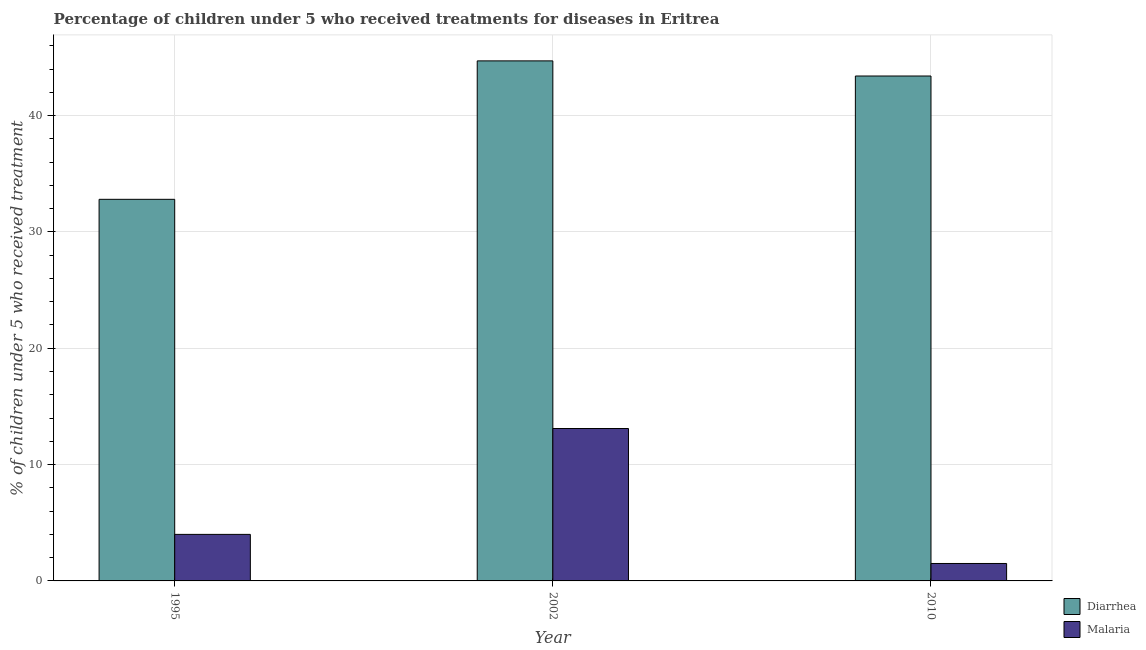How many groups of bars are there?
Your answer should be very brief. 3. What is the label of the 3rd group of bars from the left?
Provide a succinct answer. 2010. Across all years, what is the maximum percentage of children who received treatment for diarrhoea?
Give a very brief answer. 44.7. Across all years, what is the minimum percentage of children who received treatment for malaria?
Your answer should be very brief. 1.5. In which year was the percentage of children who received treatment for diarrhoea maximum?
Keep it short and to the point. 2002. What is the total percentage of children who received treatment for malaria in the graph?
Provide a succinct answer. 18.6. What is the difference between the percentage of children who received treatment for diarrhoea in 2010 and the percentage of children who received treatment for malaria in 2002?
Your response must be concise. -1.3. What is the average percentage of children who received treatment for diarrhoea per year?
Your answer should be compact. 40.3. What is the ratio of the percentage of children who received treatment for malaria in 2002 to that in 2010?
Your answer should be compact. 8.73. Is the difference between the percentage of children who received treatment for malaria in 1995 and 2002 greater than the difference between the percentage of children who received treatment for diarrhoea in 1995 and 2002?
Offer a terse response. No. What is the difference between the highest and the second highest percentage of children who received treatment for malaria?
Ensure brevity in your answer.  9.1. What is the difference between the highest and the lowest percentage of children who received treatment for diarrhoea?
Your answer should be compact. 11.9. What does the 2nd bar from the left in 1995 represents?
Make the answer very short. Malaria. What does the 2nd bar from the right in 2010 represents?
Make the answer very short. Diarrhea. What is the difference between two consecutive major ticks on the Y-axis?
Ensure brevity in your answer.  10. Does the graph contain grids?
Provide a short and direct response. Yes. Where does the legend appear in the graph?
Make the answer very short. Bottom right. How many legend labels are there?
Make the answer very short. 2. How are the legend labels stacked?
Make the answer very short. Vertical. What is the title of the graph?
Ensure brevity in your answer.  Percentage of children under 5 who received treatments for diseases in Eritrea. Does "Techinal cooperation" appear as one of the legend labels in the graph?
Offer a very short reply. No. What is the label or title of the Y-axis?
Offer a terse response. % of children under 5 who received treatment. What is the % of children under 5 who received treatment of Diarrhea in 1995?
Your response must be concise. 32.8. What is the % of children under 5 who received treatment of Malaria in 1995?
Your response must be concise. 4. What is the % of children under 5 who received treatment of Diarrhea in 2002?
Make the answer very short. 44.7. What is the % of children under 5 who received treatment in Diarrhea in 2010?
Your response must be concise. 43.4. Across all years, what is the maximum % of children under 5 who received treatment in Diarrhea?
Provide a short and direct response. 44.7. Across all years, what is the maximum % of children under 5 who received treatment in Malaria?
Offer a terse response. 13.1. Across all years, what is the minimum % of children under 5 who received treatment in Diarrhea?
Offer a terse response. 32.8. Across all years, what is the minimum % of children under 5 who received treatment of Malaria?
Offer a very short reply. 1.5. What is the total % of children under 5 who received treatment in Diarrhea in the graph?
Offer a terse response. 120.9. What is the total % of children under 5 who received treatment of Malaria in the graph?
Provide a short and direct response. 18.6. What is the difference between the % of children under 5 who received treatment of Diarrhea in 1995 and that in 2002?
Offer a terse response. -11.9. What is the difference between the % of children under 5 who received treatment in Malaria in 1995 and that in 2010?
Provide a short and direct response. 2.5. What is the difference between the % of children under 5 who received treatment in Malaria in 2002 and that in 2010?
Your response must be concise. 11.6. What is the difference between the % of children under 5 who received treatment in Diarrhea in 1995 and the % of children under 5 who received treatment in Malaria in 2010?
Ensure brevity in your answer.  31.3. What is the difference between the % of children under 5 who received treatment in Diarrhea in 2002 and the % of children under 5 who received treatment in Malaria in 2010?
Your response must be concise. 43.2. What is the average % of children under 5 who received treatment in Diarrhea per year?
Make the answer very short. 40.3. What is the average % of children under 5 who received treatment in Malaria per year?
Offer a very short reply. 6.2. In the year 1995, what is the difference between the % of children under 5 who received treatment in Diarrhea and % of children under 5 who received treatment in Malaria?
Offer a terse response. 28.8. In the year 2002, what is the difference between the % of children under 5 who received treatment in Diarrhea and % of children under 5 who received treatment in Malaria?
Your response must be concise. 31.6. In the year 2010, what is the difference between the % of children under 5 who received treatment in Diarrhea and % of children under 5 who received treatment in Malaria?
Ensure brevity in your answer.  41.9. What is the ratio of the % of children under 5 who received treatment of Diarrhea in 1995 to that in 2002?
Offer a very short reply. 0.73. What is the ratio of the % of children under 5 who received treatment in Malaria in 1995 to that in 2002?
Your answer should be very brief. 0.31. What is the ratio of the % of children under 5 who received treatment of Diarrhea in 1995 to that in 2010?
Offer a terse response. 0.76. What is the ratio of the % of children under 5 who received treatment of Malaria in 1995 to that in 2010?
Ensure brevity in your answer.  2.67. What is the ratio of the % of children under 5 who received treatment in Diarrhea in 2002 to that in 2010?
Keep it short and to the point. 1.03. What is the ratio of the % of children under 5 who received treatment of Malaria in 2002 to that in 2010?
Make the answer very short. 8.73. What is the difference between the highest and the second highest % of children under 5 who received treatment in Malaria?
Provide a succinct answer. 9.1. What is the difference between the highest and the lowest % of children under 5 who received treatment of Diarrhea?
Your response must be concise. 11.9. 